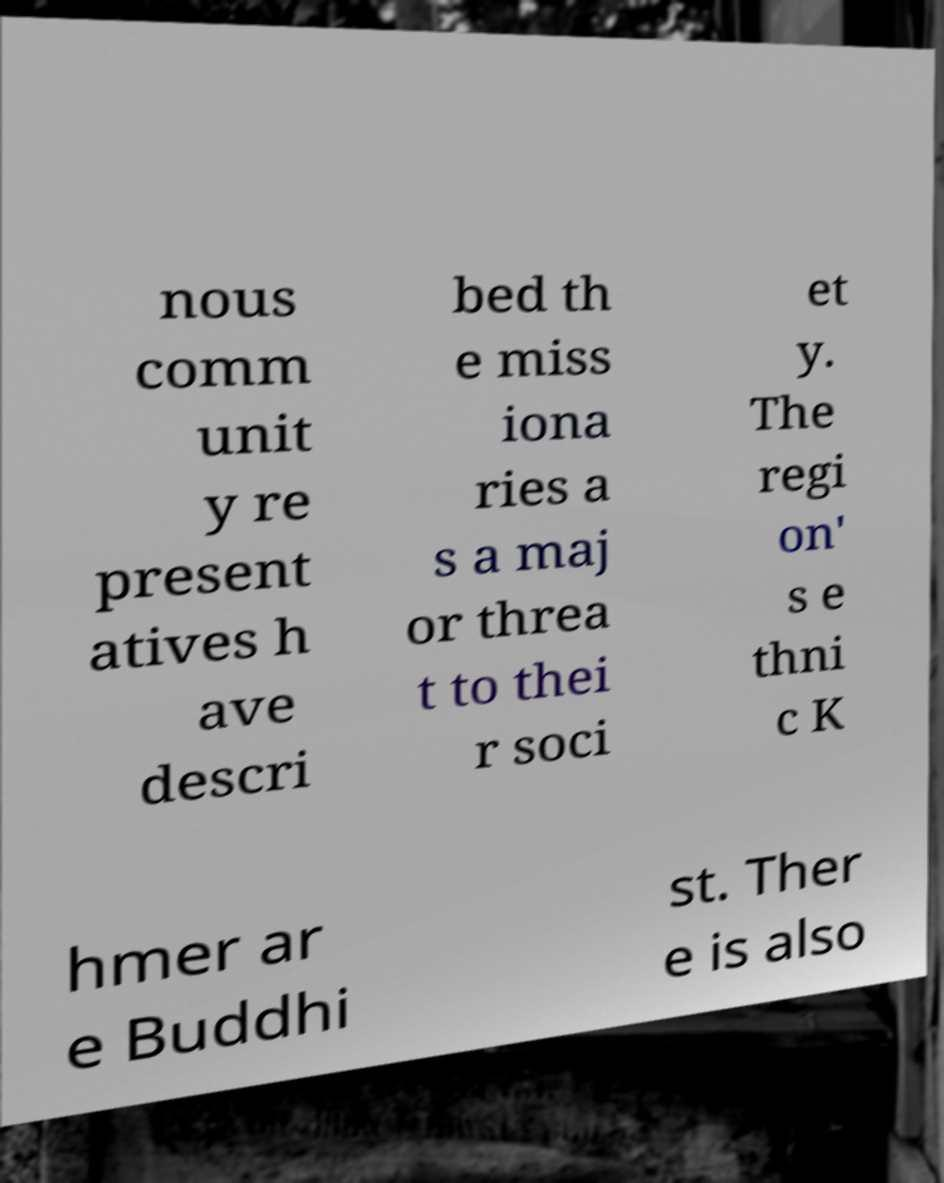Could you assist in decoding the text presented in this image and type it out clearly? nous comm unit y re present atives h ave descri bed th e miss iona ries a s a maj or threa t to thei r soci et y. The regi on' s e thni c K hmer ar e Buddhi st. Ther e is also 